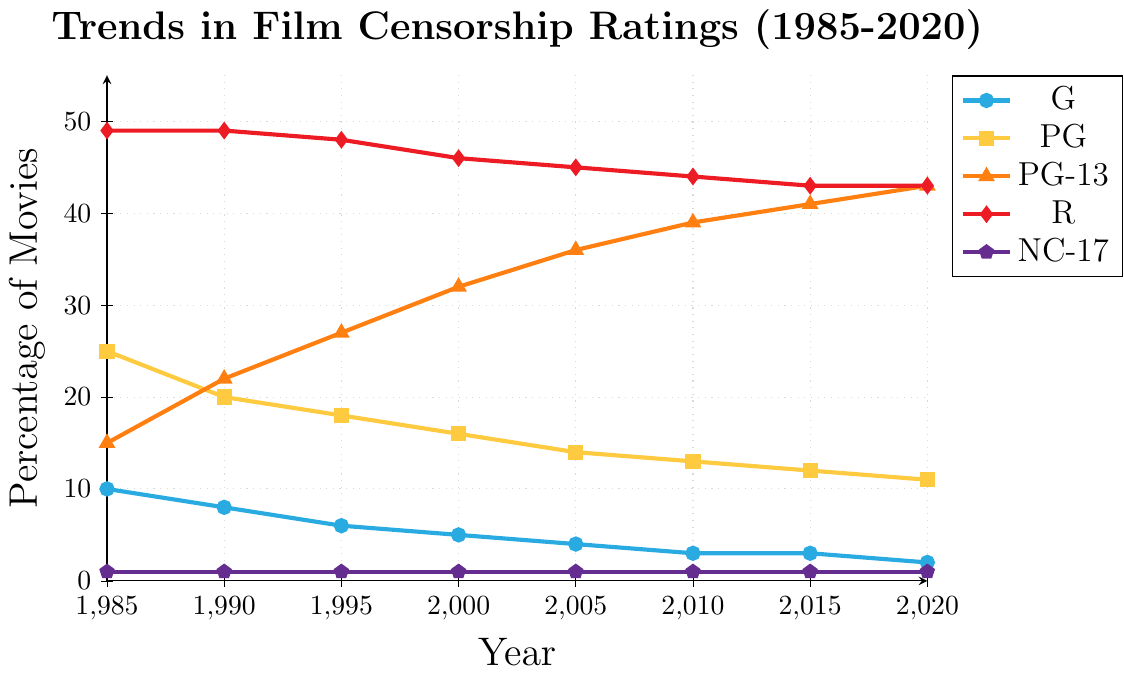What percentage of movies were rated G in 2000? According to the figure, the percentage of movies rated G in the year 2000 is marked as 5%.
Answer: 5% How has the percentage of PG-13 movies changed from 1985 to 2020? The figure shows that in 1985, the percentage of PG-13 movies was 15%. By 2020, this percentage had increased to 43%. Thus, the change is calculated as 43% - 15% = 28%.
Answer: Increased by 28% Which rating had the highest percentage in 2015? In 2015, the R rating has the highest percentage among all the categories shown in the figure, with a value of 43%.
Answer: R By how much did the percentage of PG movies decrease from 1985 to 2020? In 1985, the percentage of PG movies was 25%. In 2020, it decreased to 11%. The decrease is thus 25% - 11% = 14%.
Answer: Decreased by 14% What trends do you observe in the G-rated movies over the years from 1985 to 2020? The figure indicates that the percentage of G-rated movies has been consistently declining over the years. From 10% in 1985, it gradually decreased to 2% by 2020.
Answer: Consistent decline Identify the years when the percentage of R-rated movies was equal. The figure shows that the R-rated movies had an equal percentage of 49% in 1985 and 1990, and an equal percentage of 43% in both 2015 and 2020.
Answer: 1985, 1990, 2015, 2020 How does the frequency of NC-17 rated movies compare to the other ratings over the years? According to the figure, NC-17 rated movies consistently remain at 1% across all the years from 1985 to 2020, making it the least frequent compared to other ratings which varied over the years.
Answer: Least frequent, consistently 1% Between 1985 and 2020, which rating showed the most significant increase? The figure shows that PG-13 movies had the most significant increase over the years, from 15% in 1985 to 43% in 2020. This constitutes a total increase of 28 percentage points, more than any other rating changes.
Answer: PG-13 Compare the total percentage of movies rated G and PG in 1985 to their total percentage in 2020. In 1985, G-rated movies were 10% and PG-rated were 25%, summing up to a total of 35%. In 2020, G-rated movies were 2% and PG-rated were 11%, summing up to a total of 13%. Thus, the total percentage decreased from 35% to 13%.
Answer: Decreased from 35% to 13% 